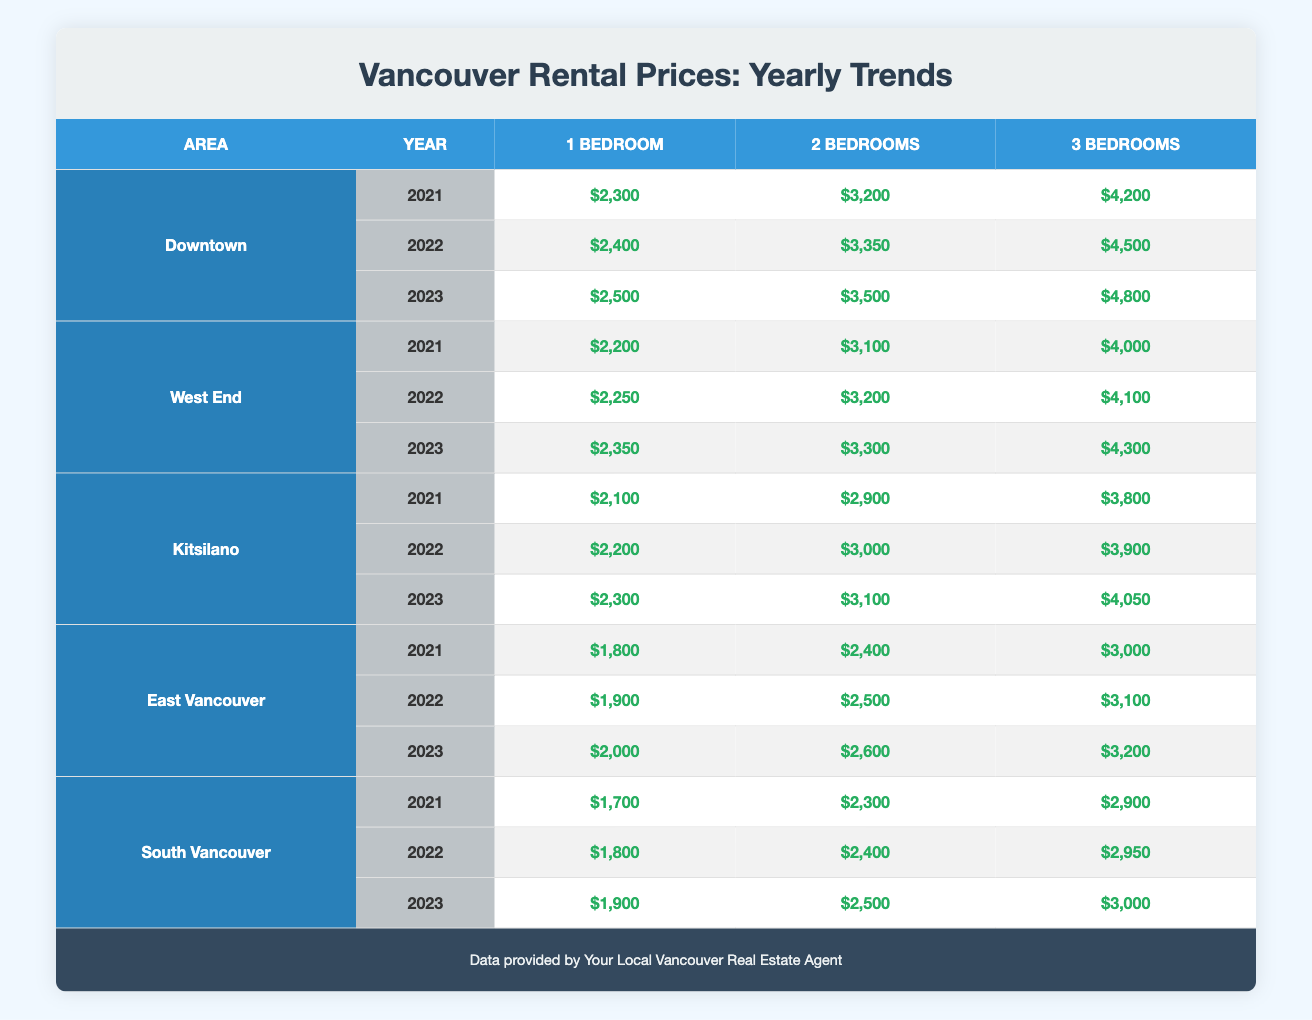What is the rental price for a 2-bedroom apartment in Downtown during 2023? The table shows that the rental price for a 2-bedroom apartment in Downtown in 2023 is $3,500.
Answer: $3,500 What was the price increase for a 1-bedroom apartment in Kitsilano from 2021 to 2023? The rental price for a 1-bedroom apartment in Kitsilano was $2,100 in 2021 and $2,300 in 2023. The increase is $2,300 - $2,100 = $200.
Answer: $200 Is the average price for a 3-bedroom apartment in East Vancouver higher than in South Vancouver in 2022? In 2022, the rental price for a 3-bedroom apartment in East Vancouver is $3,100, while in South Vancouver it is $2,950. Since $3,100 > $2,950, it is true that East Vancouver is higher.
Answer: Yes What is the total rental price for a 2-bedroom apartment in West End over the years 2021, 2022, and 2023? The rental prices for a 2-bedroom apartment in West End were $3,100 in 2021, $3,200 in 2022, and $3,300 in 2023. Adding them gives $3,100 + $3,200 + $3,300 = $9,600.
Answer: $9,600 Which area had the highest 3-bedroom rental price in 2021? By comparing the 3-bedroom prices in all areas for 2021, Downtown had $4,200, which is higher than the others (West End at $4,000, Kitsilano at $3,800, East Vancouver at $3,000, and South Vancouver at $2,900).
Answer: Downtown What was the price difference for a 2-bedroom apartment between 2021 and 2023 in Kitsilano? The rental price for a 2-bedroom apartment in Kitsilano in 2021 was $2,900 and in 2023 it was $3,100. The difference is $3,100 - $2,900 = $200.
Answer: $200 In which year did East Vancouver see the biggest jump in rental prices for 1-bedroom apartments? The prices for 1-bedroom apartments in East Vancouver were $1,800 in 2021, $1,900 in 2022, and $2,000 in 2023. The biggest increase occurred between 2022 and 2023, which was $2,000 - $1,900 = $100.
Answer: $100 Are the rental prices for 2-bedroom apartments in South Vancouver consistently lower than in Downtown across the three years? In Downtown, the prices for 2-bedroom apartments were $3,200 (2021), $3,350 (2022), and $3,500 (2023). In South Vancouver, they were $2,300 (2021), $2,400 (2022), and $2,500 (2023). Since all prices in South Vancouver are lower, the answer is true.
Answer: Yes 